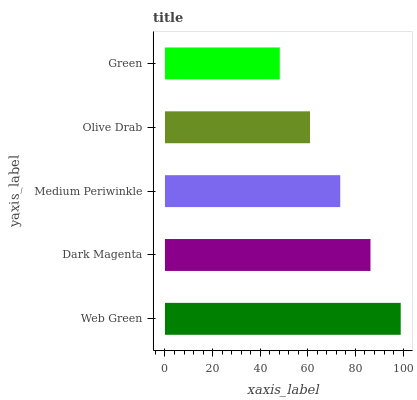Is Green the minimum?
Answer yes or no. Yes. Is Web Green the maximum?
Answer yes or no. Yes. Is Dark Magenta the minimum?
Answer yes or no. No. Is Dark Magenta the maximum?
Answer yes or no. No. Is Web Green greater than Dark Magenta?
Answer yes or no. Yes. Is Dark Magenta less than Web Green?
Answer yes or no. Yes. Is Dark Magenta greater than Web Green?
Answer yes or no. No. Is Web Green less than Dark Magenta?
Answer yes or no. No. Is Medium Periwinkle the high median?
Answer yes or no. Yes. Is Medium Periwinkle the low median?
Answer yes or no. Yes. Is Web Green the high median?
Answer yes or no. No. Is Olive Drab the low median?
Answer yes or no. No. 